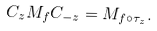Convert formula to latex. <formula><loc_0><loc_0><loc_500><loc_500>C _ { z } M _ { f } C _ { - z } = M _ { f \circ \tau _ { z } } .</formula> 